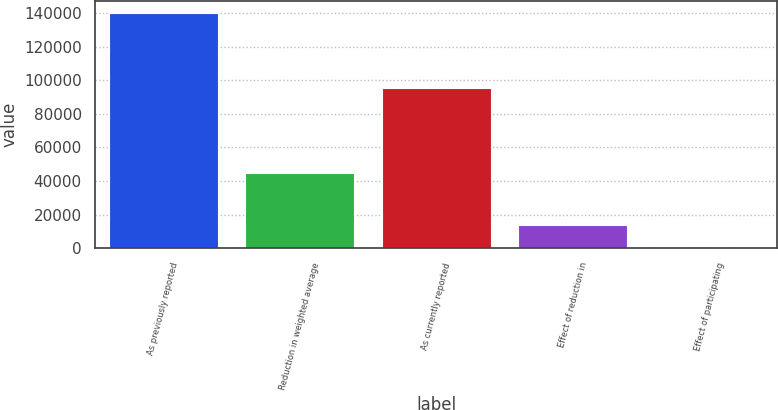<chart> <loc_0><loc_0><loc_500><loc_500><bar_chart><fcel>As previously reported<fcel>Reduction in weighted average<fcel>As currently reported<fcel>Effect of reduction in<fcel>Effect of participating<nl><fcel>140137<fcel>45030<fcel>95107<fcel>14013.8<fcel>0.05<nl></chart> 